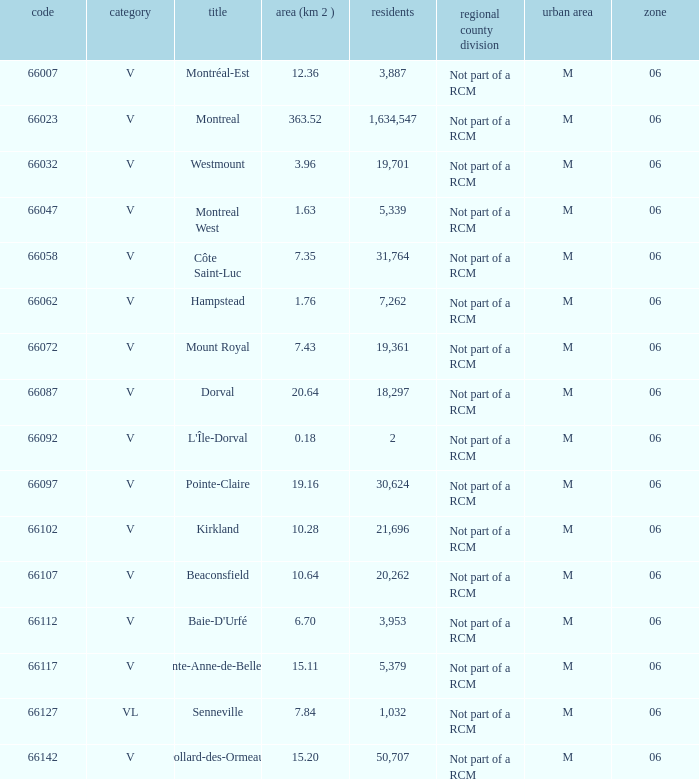What is the largest region with a Code smaller than 66112, and a Name of l'île-dorval? 6.0. 